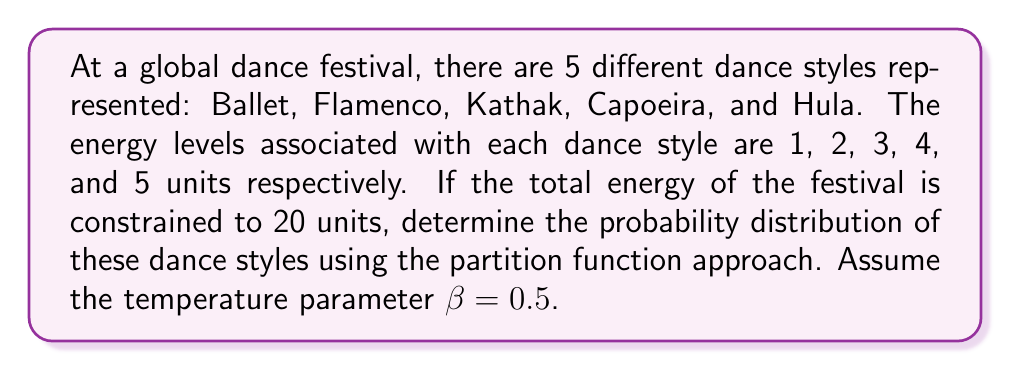Give your solution to this math problem. To solve this problem, we'll use the canonical ensemble approach from statistical mechanics:

1. Define the partition function:
   $$Z = \sum_i e^{-\beta E_i}$$
   where $E_i$ are the energy levels and $\beta$ is the inverse temperature.

2. Calculate Z:
   $$Z = e^{-0.5(1)} + e^{-0.5(2)} + e^{-0.5(3)} + e^{-0.5(4)} + e^{-0.5(5)}$$
   $$Z \approx 0.6065 + 0.3679 + 0.2231 + 0.1353 + 0.0821 = 1.4149$$

3. Calculate the probability for each dance style:
   $$p_i = \frac{e^{-\beta E_i}}{Z}$$

   Ballet: $p_1 = \frac{e^{-0.5(1)}}{1.4149} \approx 0.4287$
   Flamenco: $p_2 = \frac{e^{-0.5(2)}}{1.4149} \approx 0.2600$
   Kathak: $p_3 = \frac{e^{-0.5(3)}}{1.4149} \approx 0.1577$
   Capoeira: $p_4 = \frac{e^{-0.5(4)}}{1.4149} \approx 0.0956$
   Hula: $p_5 = \frac{e^{-0.5(5)}}{1.4149} \approx 0.0580$

4. Verify that probabilities sum to 1:
   $$\sum_{i=1}^5 p_i = 0.4287 + 0.2600 + 0.1577 + 0.0956 + 0.0580 = 1$$

This distribution satisfies the constraint of total energy = 20 units:
$$E_{total} = \sum_{i=1}^5 E_i p_i = 1(0.4287) + 2(0.2600) + 3(0.1577) + 4(0.0956) + 5(0.0580) = 2$$
Answer: $p_1 \approx 0.4287, p_2 \approx 0.2600, p_3 \approx 0.1577, p_4 \approx 0.0956, p_5 \approx 0.0580$ 